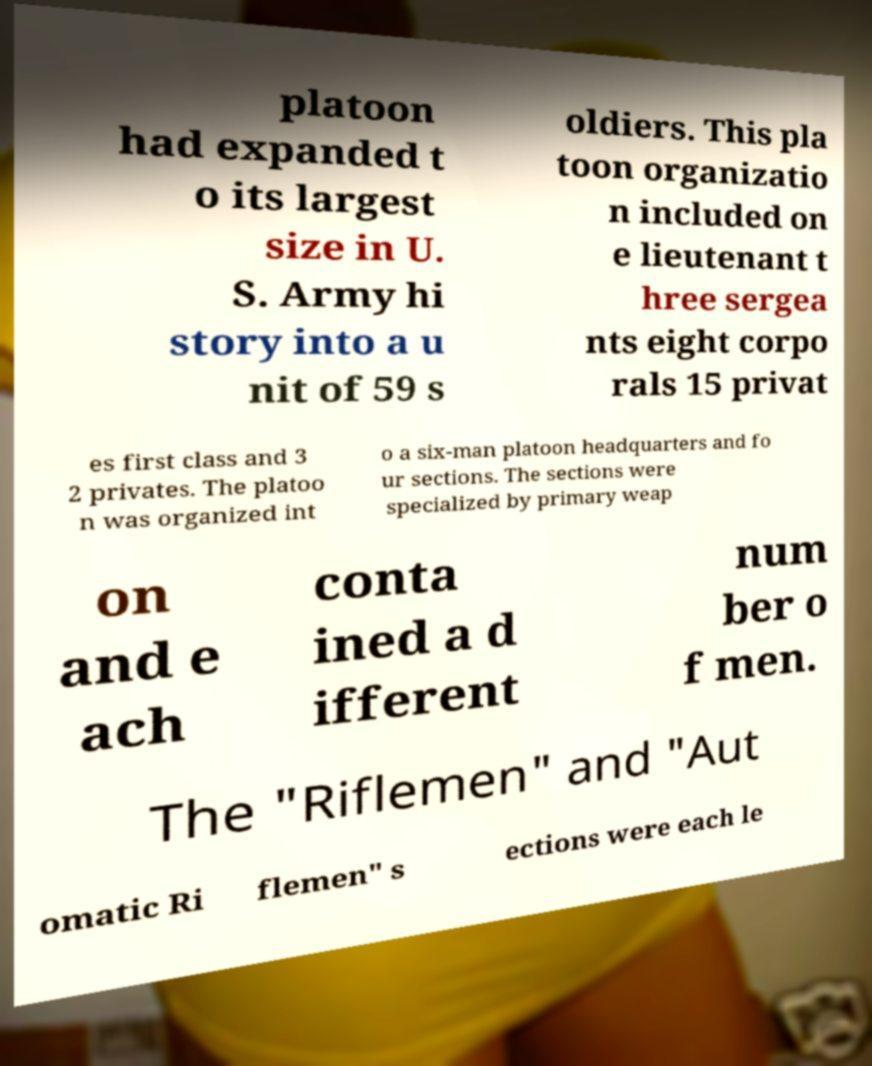I need the written content from this picture converted into text. Can you do that? platoon had expanded t o its largest size in U. S. Army hi story into a u nit of 59 s oldiers. This pla toon organizatio n included on e lieutenant t hree sergea nts eight corpo rals 15 privat es first class and 3 2 privates. The platoo n was organized int o a six-man platoon headquarters and fo ur sections. The sections were specialized by primary weap on and e ach conta ined a d ifferent num ber o f men. The "Riflemen" and "Aut omatic Ri flemen" s ections were each le 